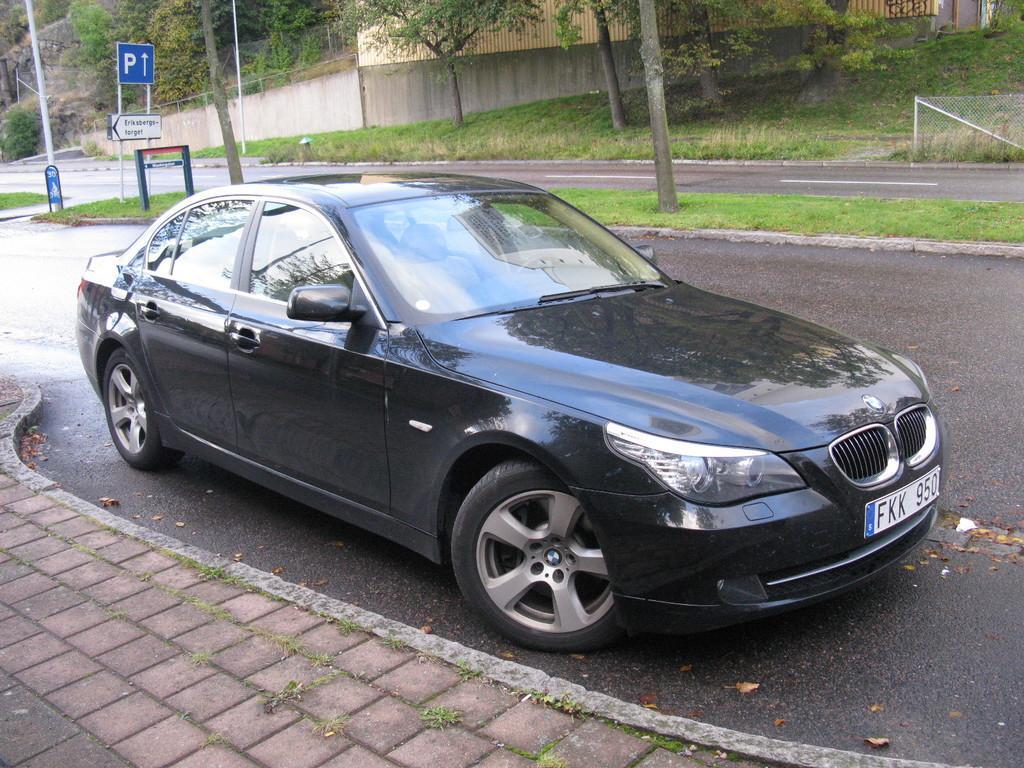In one or two sentences, can you explain what this image depicts? In this picture I can observe a black color car on the road. I can observe footpath beside the car. On the left side there are two boards in blue and white color. In the background there are some trees. 